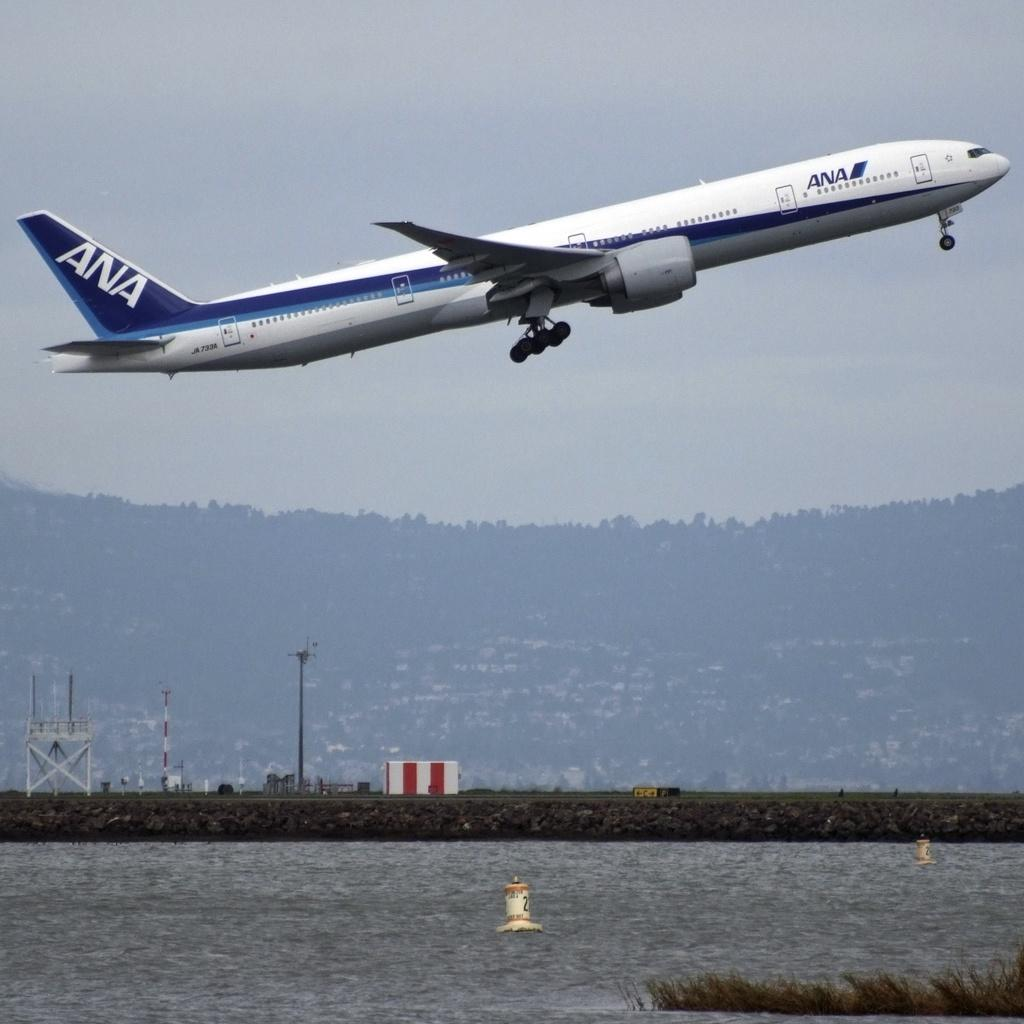<image>
Write a terse but informative summary of the picture. White ANA airplane about to takeoff into the cloudy day. 